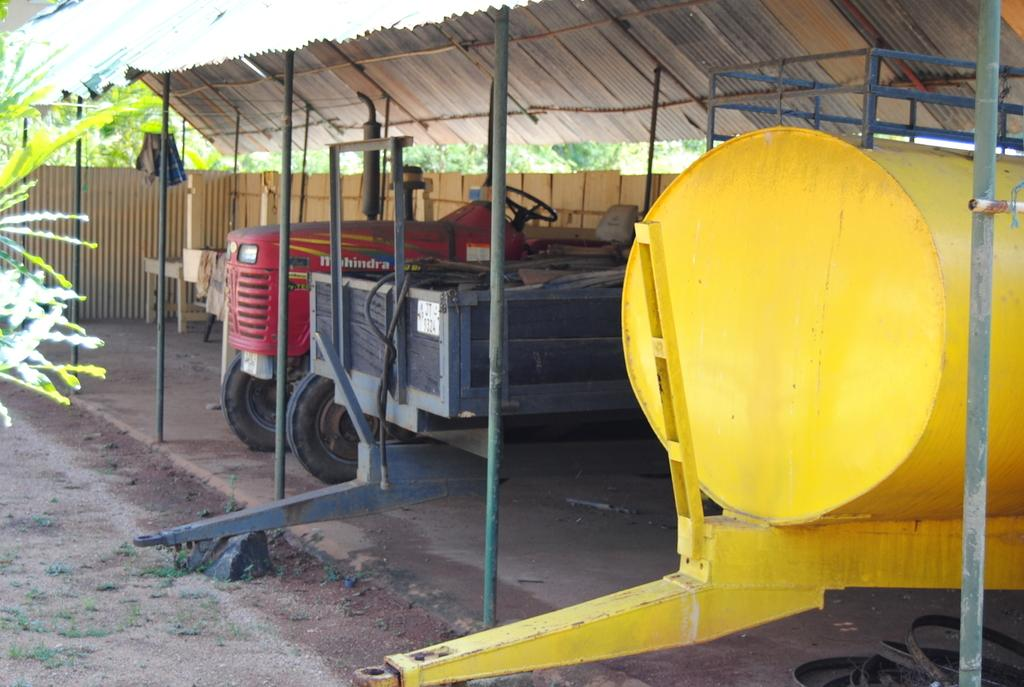What is the main subject in the middle of the picture? There is a red tractor in the middle of the picture. What other vehicle can be seen on the right side of the picture? There is a yellow tanker on the right side of the picture. What can be seen in the background of the picture? There are trees in the background of the picture. How many stitches are visible on the tractor's seat in the image? There are no stitches visible on the tractor's seat in the image, as it is a photograph of a vehicle and not a piece of fabric. 